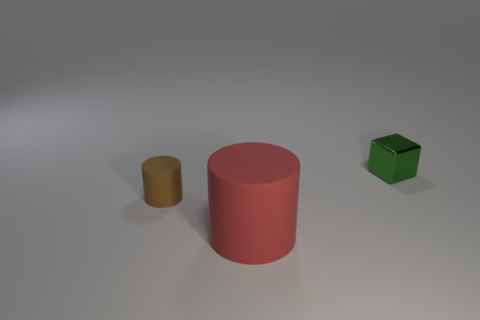Add 3 big matte things. How many objects exist? 6 Subtract all cylinders. How many objects are left? 1 Subtract 0 brown blocks. How many objects are left? 3 Subtract all big red cylinders. Subtract all large red objects. How many objects are left? 1 Add 3 small green metal things. How many small green metal things are left? 4 Add 1 red cylinders. How many red cylinders exist? 2 